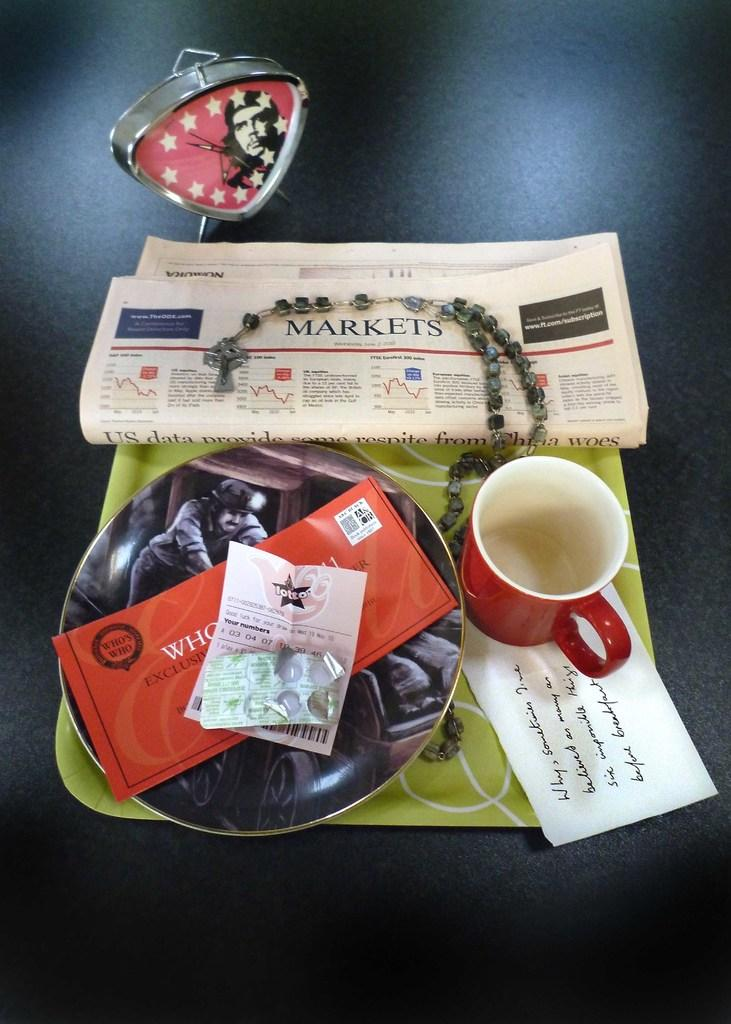<image>
Offer a succinct explanation of the picture presented. A tray contains a number of objects, including a paper open to the markets section. 